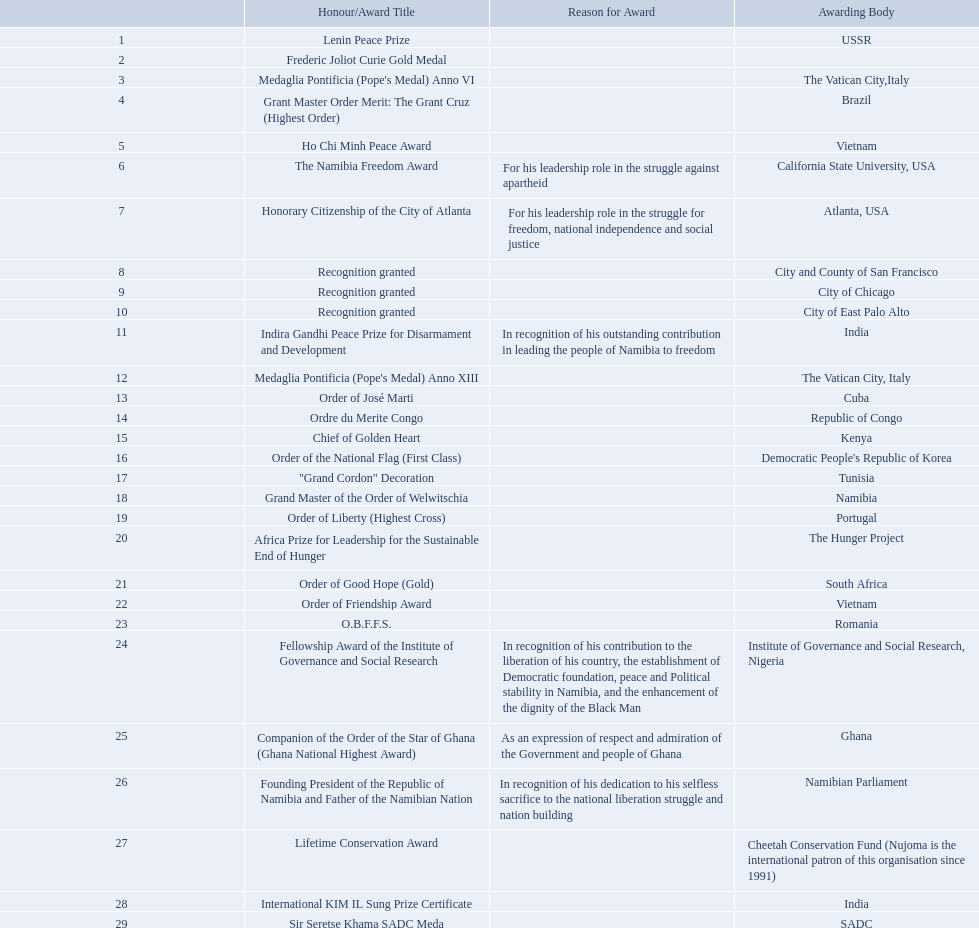Which awarding bodies have recognized sam nujoma? USSR, , The Vatican City,Italy, Brazil, Vietnam, California State University, USA, Atlanta, USA, City and County of San Francisco, City of Chicago, City of East Palo Alto, India, The Vatican City, Italy, Cuba, Republic of Congo, Kenya, Democratic People's Republic of Korea, Tunisia, Namibia, Portugal, The Hunger Project, South Africa, Vietnam, Romania, Institute of Governance and Social Research, Nigeria, Ghana, Namibian Parliament, Cheetah Conservation Fund (Nujoma is the international patron of this organisation since 1991), India, SADC. And what was the title of each award or honour? Lenin Peace Prize, Frederic Joliot Curie Gold Medal, Medaglia Pontificia (Pope's Medal) Anno VI, Grant Master Order Merit: The Grant Cruz (Highest Order), Ho Chi Minh Peace Award, The Namibia Freedom Award, Honorary Citizenship of the City of Atlanta, Recognition granted, Recognition granted, Recognition granted, Indira Gandhi Peace Prize for Disarmament and Development, Medaglia Pontificia (Pope's Medal) Anno XIII, Order of José Marti, Ordre du Merite Congo, Chief of Golden Heart, Order of the National Flag (First Class), "Grand Cordon" Decoration, Grand Master of the Order of Welwitschia, Order of Liberty (Highest Cross), Africa Prize for Leadership for the Sustainable End of Hunger, Order of Good Hope (Gold), Order of Friendship Award, O.B.F.F.S., Fellowship Award of the Institute of Governance and Social Research, Companion of the Order of the Star of Ghana (Ghana National Highest Award), Founding President of the Republic of Namibia and Father of the Namibian Nation, Lifetime Conservation Award, International KIM IL Sung Prize Certificate, Sir Seretse Khama SADC Meda. Of those, which nation awarded him the o.b.f.f.s.? Romania. 